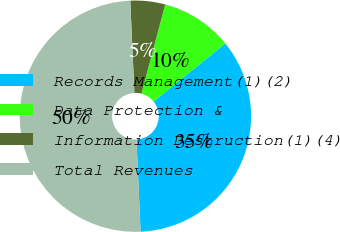<chart> <loc_0><loc_0><loc_500><loc_500><pie_chart><fcel>Records Management(1)(2)<fcel>Data Protection &<fcel>Information Destruction(1)(4)<fcel>Total Revenues<nl><fcel>35.13%<fcel>10.02%<fcel>4.86%<fcel>50.0%<nl></chart> 